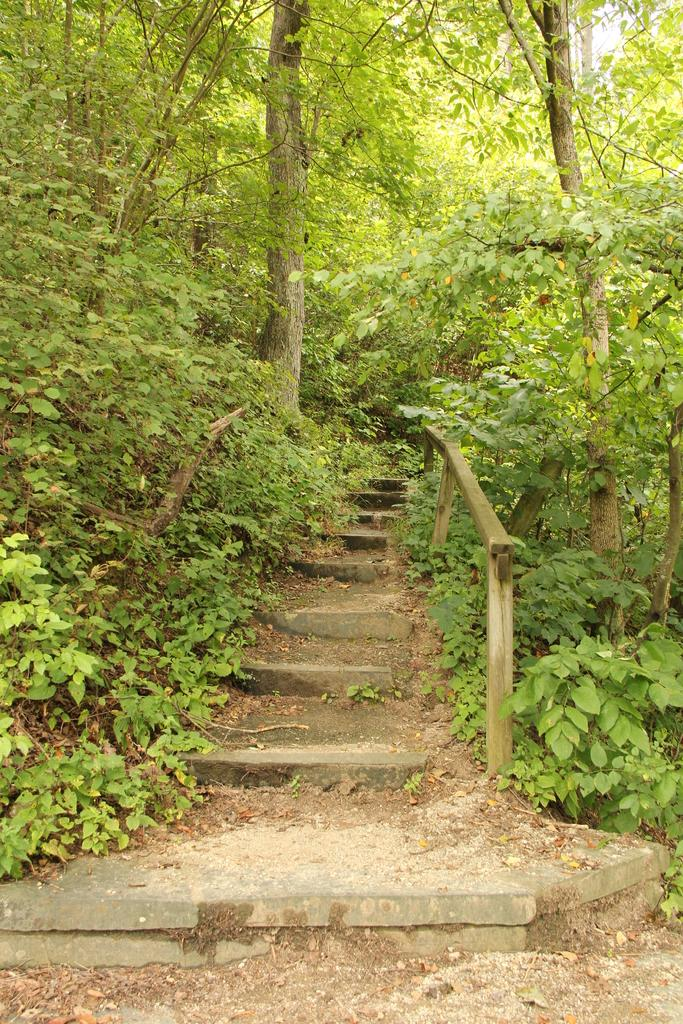What type of architectural feature is present in the image? There are steps in the image. What is located near the steps? There are plants on the ground beside the steps. What can be seen in the background of the image? There are trees in the background of the image. What is visible at the bottom of the image? The ground is visible at the bottom of the image. What type of machine is being used to reduce friction on the steps in the image? There is no machine present in the image, nor is there any indication of friction or its reduction. 